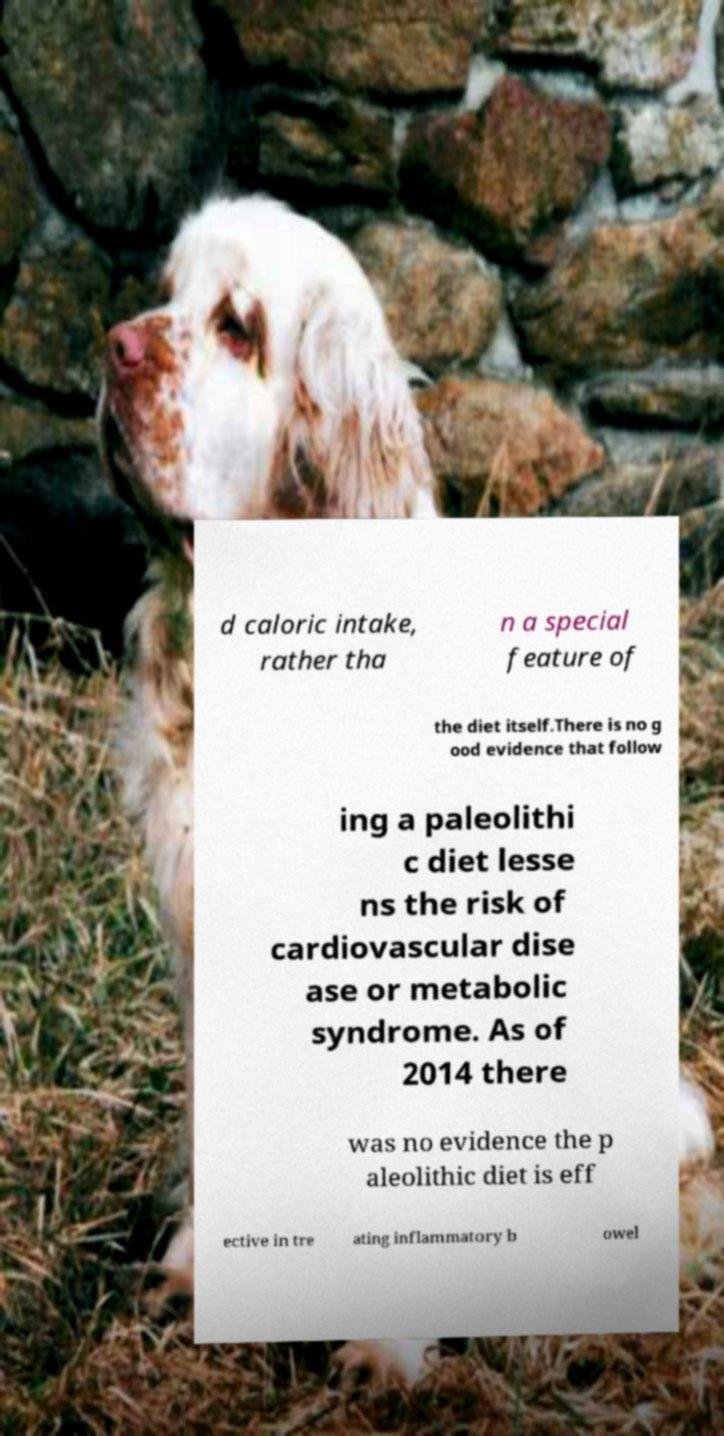For documentation purposes, I need the text within this image transcribed. Could you provide that? d caloric intake, rather tha n a special feature of the diet itself.There is no g ood evidence that follow ing a paleolithi c diet lesse ns the risk of cardiovascular dise ase or metabolic syndrome. As of 2014 there was no evidence the p aleolithic diet is eff ective in tre ating inflammatory b owel 